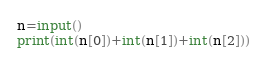<code> <loc_0><loc_0><loc_500><loc_500><_Python_>n=input()
print(int(n[0])+int(n[1])+int(n[2]))</code> 